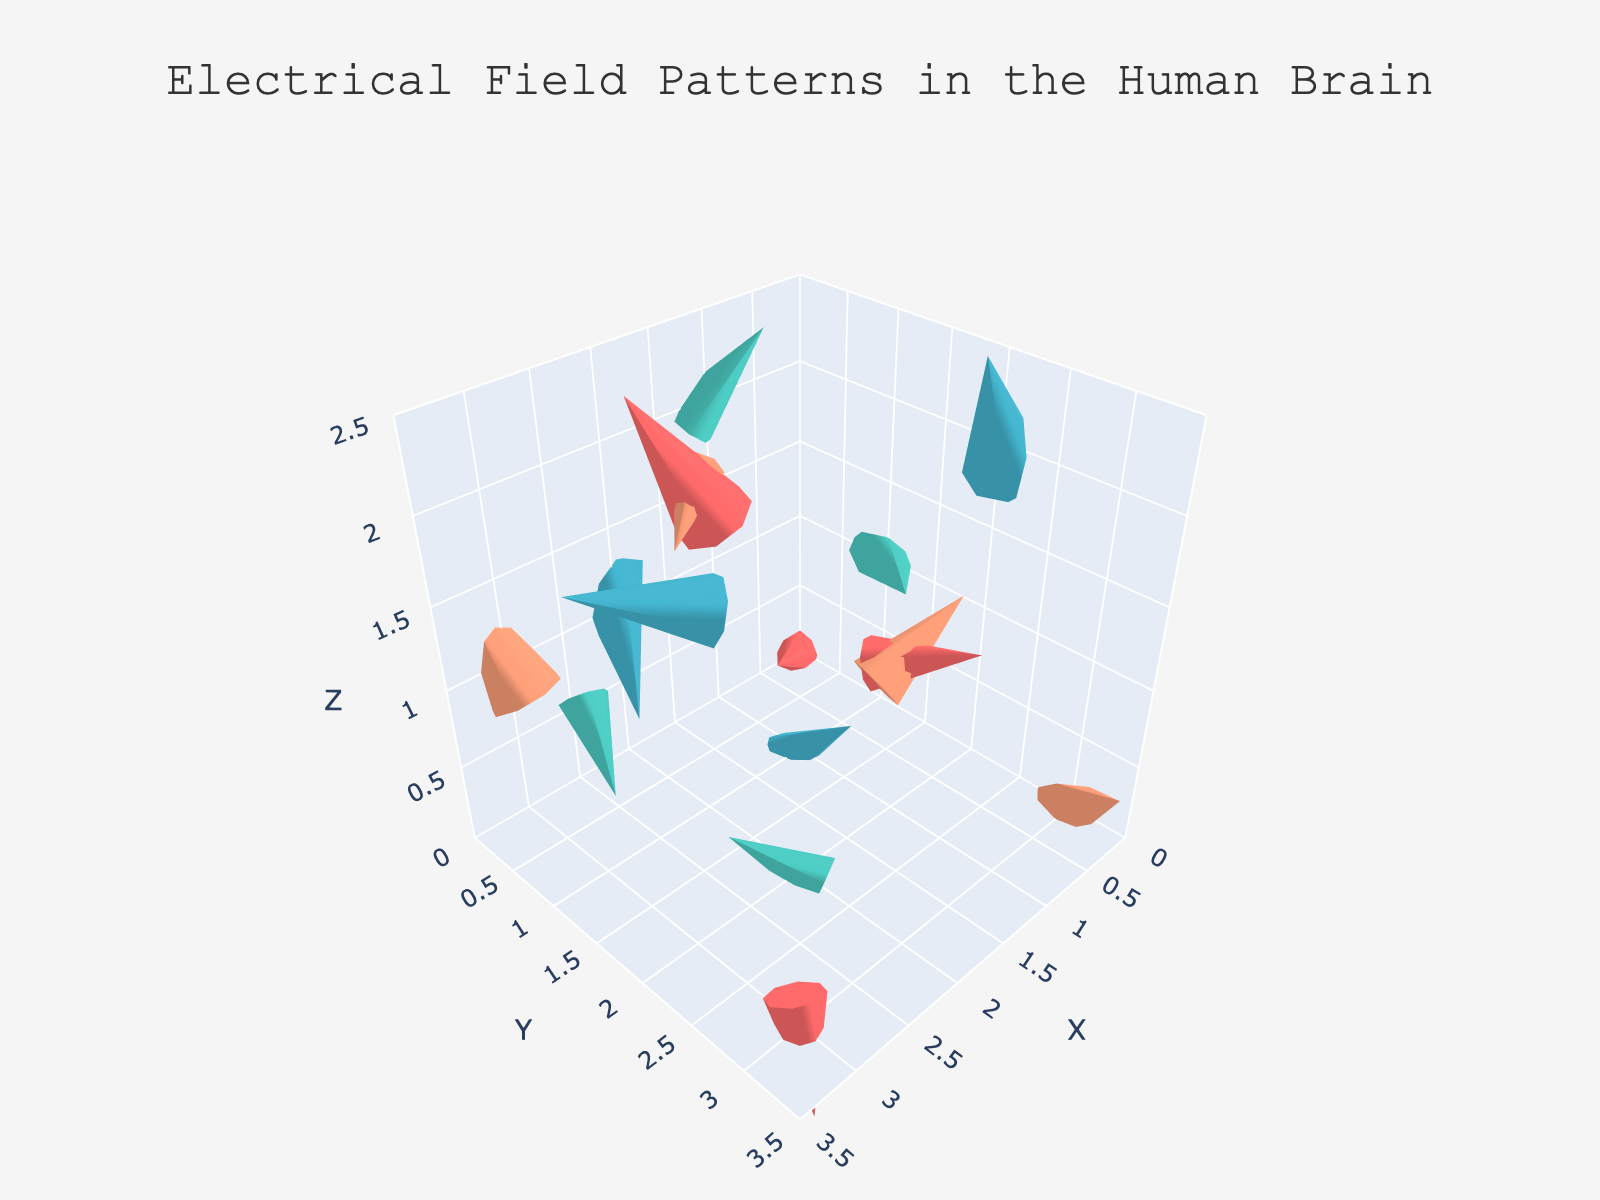What is the title of the figure? The title of the figure is displayed at the top of the plot, indicating the main subject.
Answer: Electrical Field Patterns in the Human Brain How many different cognitive tasks are displayed in the figure? The legend lists the different cognitive tasks represented in the plot.
Answer: Four What color represents the "Reading MRI" task? The legend includes colors corresponding to each task, where "Reading MRI" is shown in its color.
Answer: Red How is the strength of neural activity visually represented in the plot? The strength of neural activity is shown by the length of the arrows, where longer arrows represent stronger activity.
Answer: Length of arrows Which task shows the strongest neural activity in the X-direction? By examining the plot and focusing on the arrows' length in the X-direction, we can identify the task with the longest arrow in that direction.
Answer: Reading MRI What is the direction of the vector at (1, 2, 1) for the "Memory recall" task? Locate the position (1, 2, 1) in the "Memory recall" task and read the direction of the corresponding arrow, indicated in the hover text.
Answer: (-0.3, 0.2, 0.3) How does the neural activity compare between "Problem solving" and "Language processing" at the X=2 position? Compare the length and direction of arrows at positions on the X=2 line for both tasks to evaluate similarities and differences.
Answer: Problem solving shows more activity Which cognitive task has the most vertical activity? Examine the arrows in the Z-direction across all tasks and determine which task has the longest arrows pointing vertically.
Answer: Language processing What is the average Z-coordinate of the vectors for the "Reading MRI" task? Identify all Z-coordinates for the "Reading MRI" task vectors, sum them up, and divide by the number of vectors.
Answer: 0.75 What task has the predominant activity in the positive Y-direction near the origin? Check the vectors near the origin for each task and determine which has the majority of vectors pointing in the positive Y-direction.
Answer: Reading MRI 